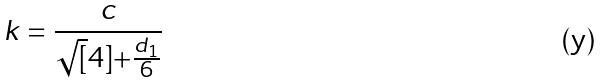<formula> <loc_0><loc_0><loc_500><loc_500>k = \frac { c } { \sqrt { [ } 4 ] { + \frac { d _ { 1 } } { 6 } } }</formula> 